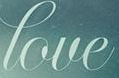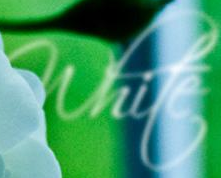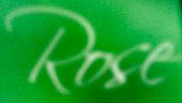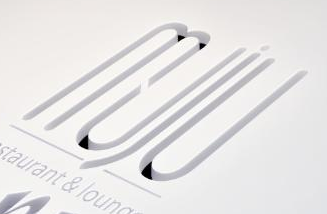Read the text content from these images in order, separated by a semicolon. love; white; Rose; muju 